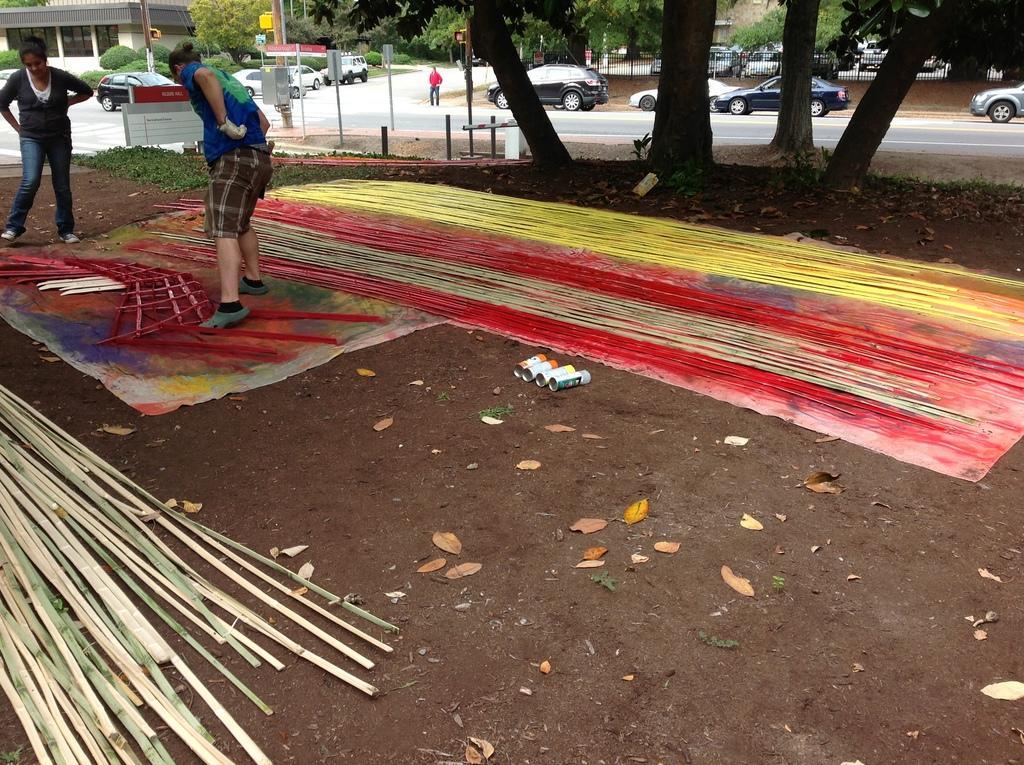Can you describe this image briefly? In this picture we can see group of people, few trees, buildings, poles and vehicles, on the left side of the image we can find few wooden sticks, and also we can see color threads. 